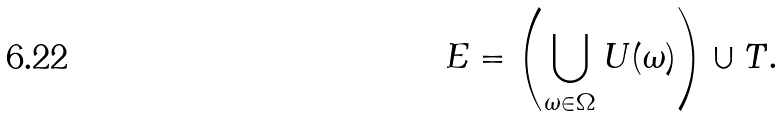<formula> <loc_0><loc_0><loc_500><loc_500>E = \left ( \bigcup _ { \omega \in \Omega } U ( \omega ) \right ) \cup T .</formula> 